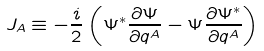Convert formula to latex. <formula><loc_0><loc_0><loc_500><loc_500>J _ { A } \equiv - \frac { i } { 2 } \left ( \Psi ^ { * } \frac { \partial \Psi } { \partial q ^ { A } } - \Psi \frac { \partial \Psi ^ { * } } { \partial q ^ { A } } \right )</formula> 